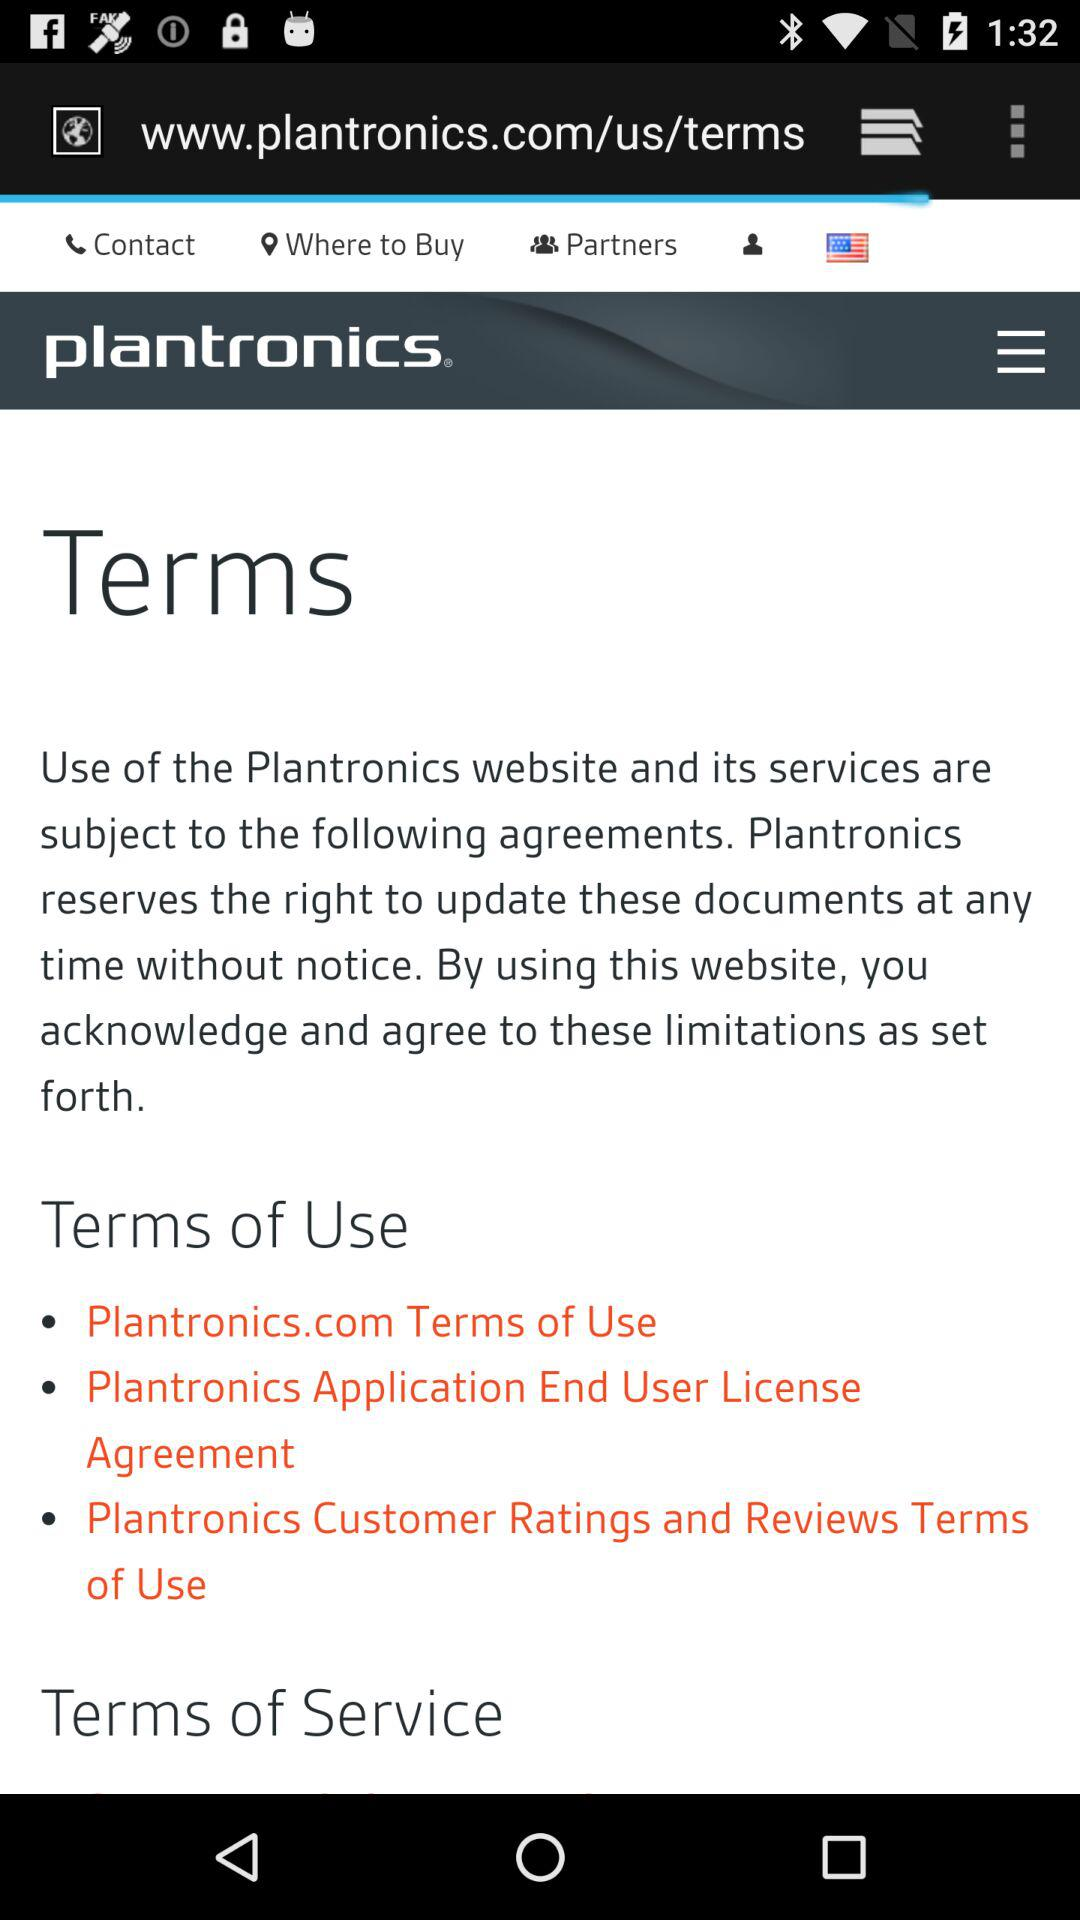How many terms does Plantronics have?
Answer the question using a single word or phrase. 3 